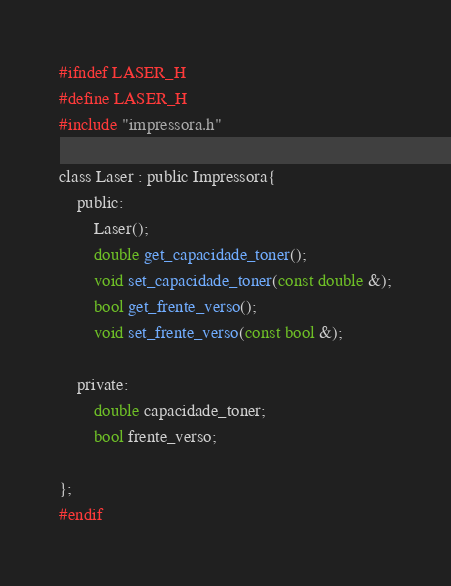Convert code to text. <code><loc_0><loc_0><loc_500><loc_500><_C_>#ifndef LASER_H
#define LASER_H
#include "impressora.h"

class Laser : public Impressora{
    public:
        Laser();
        double get_capacidade_toner();
        void set_capacidade_toner(const double &);
        bool get_frente_verso();
        void set_frente_verso(const bool &);
        
    private:
        double capacidade_toner;
        bool frente_verso;

};
#endif</code> 